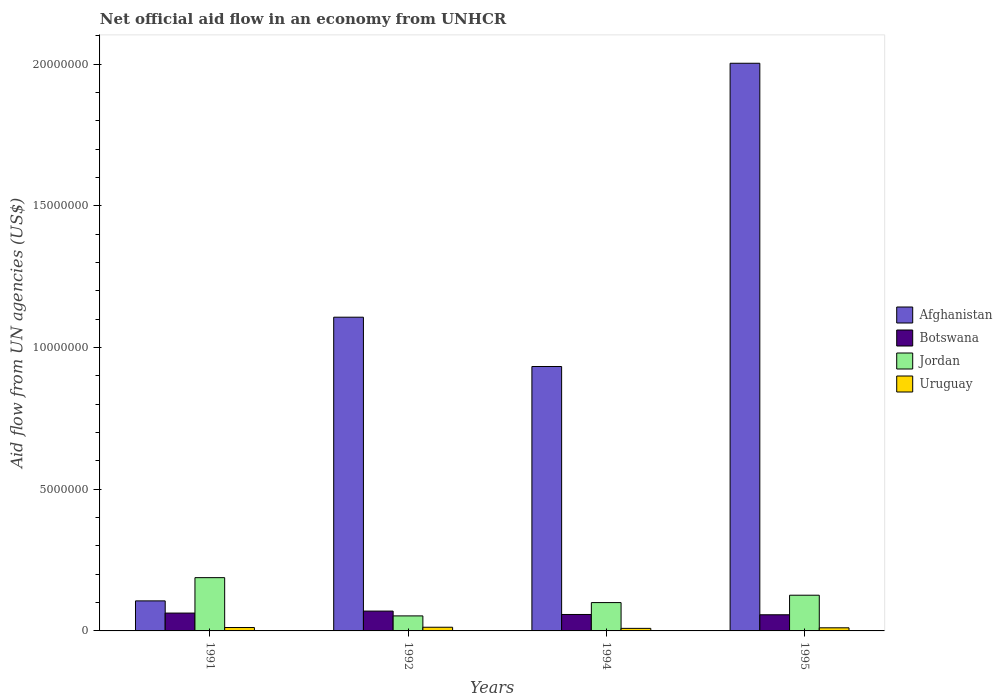How many different coloured bars are there?
Give a very brief answer. 4. Are the number of bars on each tick of the X-axis equal?
Ensure brevity in your answer.  Yes. How many bars are there on the 1st tick from the left?
Keep it short and to the point. 4. Across all years, what is the maximum net official aid flow in Afghanistan?
Make the answer very short. 2.00e+07. Across all years, what is the minimum net official aid flow in Jordan?
Provide a succinct answer. 5.30e+05. In which year was the net official aid flow in Jordan maximum?
Provide a succinct answer. 1991. In which year was the net official aid flow in Afghanistan minimum?
Keep it short and to the point. 1991. What is the total net official aid flow in Uruguay in the graph?
Your answer should be compact. 4.50e+05. What is the difference between the net official aid flow in Botswana in 1992 and that in 1994?
Make the answer very short. 1.20e+05. What is the difference between the net official aid flow in Afghanistan in 1994 and the net official aid flow in Uruguay in 1995?
Offer a terse response. 9.22e+06. What is the average net official aid flow in Uruguay per year?
Offer a terse response. 1.12e+05. In how many years, is the net official aid flow in Afghanistan greater than 4000000 US$?
Ensure brevity in your answer.  3. What is the ratio of the net official aid flow in Jordan in 1992 to that in 1995?
Your answer should be compact. 0.42. Is the net official aid flow in Botswana in 1992 less than that in 1994?
Give a very brief answer. No. What is the difference between the highest and the second highest net official aid flow in Jordan?
Your answer should be compact. 6.20e+05. What is the difference between the highest and the lowest net official aid flow in Afghanistan?
Offer a very short reply. 1.90e+07. In how many years, is the net official aid flow in Afghanistan greater than the average net official aid flow in Afghanistan taken over all years?
Your answer should be very brief. 2. Is the sum of the net official aid flow in Uruguay in 1991 and 1995 greater than the maximum net official aid flow in Jordan across all years?
Provide a short and direct response. No. What does the 1st bar from the left in 1991 represents?
Your answer should be compact. Afghanistan. What does the 2nd bar from the right in 1991 represents?
Provide a short and direct response. Jordan. Is it the case that in every year, the sum of the net official aid flow in Uruguay and net official aid flow in Afghanistan is greater than the net official aid flow in Jordan?
Offer a very short reply. No. Are all the bars in the graph horizontal?
Your answer should be very brief. No. How many years are there in the graph?
Give a very brief answer. 4. What is the difference between two consecutive major ticks on the Y-axis?
Keep it short and to the point. 5.00e+06. Are the values on the major ticks of Y-axis written in scientific E-notation?
Your response must be concise. No. Where does the legend appear in the graph?
Offer a terse response. Center right. How many legend labels are there?
Offer a very short reply. 4. How are the legend labels stacked?
Offer a terse response. Vertical. What is the title of the graph?
Offer a very short reply. Net official aid flow in an economy from UNHCR. What is the label or title of the X-axis?
Ensure brevity in your answer.  Years. What is the label or title of the Y-axis?
Give a very brief answer. Aid flow from UN agencies (US$). What is the Aid flow from UN agencies (US$) of Afghanistan in 1991?
Make the answer very short. 1.06e+06. What is the Aid flow from UN agencies (US$) of Botswana in 1991?
Provide a short and direct response. 6.30e+05. What is the Aid flow from UN agencies (US$) in Jordan in 1991?
Provide a short and direct response. 1.88e+06. What is the Aid flow from UN agencies (US$) in Afghanistan in 1992?
Provide a short and direct response. 1.11e+07. What is the Aid flow from UN agencies (US$) in Jordan in 1992?
Offer a terse response. 5.30e+05. What is the Aid flow from UN agencies (US$) of Afghanistan in 1994?
Your response must be concise. 9.33e+06. What is the Aid flow from UN agencies (US$) in Botswana in 1994?
Provide a succinct answer. 5.80e+05. What is the Aid flow from UN agencies (US$) in Jordan in 1994?
Keep it short and to the point. 1.00e+06. What is the Aid flow from UN agencies (US$) in Afghanistan in 1995?
Offer a very short reply. 2.00e+07. What is the Aid flow from UN agencies (US$) of Botswana in 1995?
Your response must be concise. 5.70e+05. What is the Aid flow from UN agencies (US$) in Jordan in 1995?
Offer a terse response. 1.26e+06. Across all years, what is the maximum Aid flow from UN agencies (US$) in Afghanistan?
Your response must be concise. 2.00e+07. Across all years, what is the maximum Aid flow from UN agencies (US$) of Jordan?
Keep it short and to the point. 1.88e+06. Across all years, what is the minimum Aid flow from UN agencies (US$) of Afghanistan?
Offer a terse response. 1.06e+06. Across all years, what is the minimum Aid flow from UN agencies (US$) of Botswana?
Your answer should be compact. 5.70e+05. Across all years, what is the minimum Aid flow from UN agencies (US$) in Jordan?
Give a very brief answer. 5.30e+05. What is the total Aid flow from UN agencies (US$) in Afghanistan in the graph?
Your answer should be compact. 4.15e+07. What is the total Aid flow from UN agencies (US$) of Botswana in the graph?
Keep it short and to the point. 2.48e+06. What is the total Aid flow from UN agencies (US$) in Jordan in the graph?
Provide a succinct answer. 4.67e+06. What is the difference between the Aid flow from UN agencies (US$) of Afghanistan in 1991 and that in 1992?
Your answer should be very brief. -1.00e+07. What is the difference between the Aid flow from UN agencies (US$) of Jordan in 1991 and that in 1992?
Your answer should be compact. 1.35e+06. What is the difference between the Aid flow from UN agencies (US$) of Afghanistan in 1991 and that in 1994?
Give a very brief answer. -8.27e+06. What is the difference between the Aid flow from UN agencies (US$) of Botswana in 1991 and that in 1994?
Your answer should be compact. 5.00e+04. What is the difference between the Aid flow from UN agencies (US$) of Jordan in 1991 and that in 1994?
Your answer should be compact. 8.80e+05. What is the difference between the Aid flow from UN agencies (US$) in Afghanistan in 1991 and that in 1995?
Your response must be concise. -1.90e+07. What is the difference between the Aid flow from UN agencies (US$) of Jordan in 1991 and that in 1995?
Your answer should be very brief. 6.20e+05. What is the difference between the Aid flow from UN agencies (US$) of Afghanistan in 1992 and that in 1994?
Your answer should be compact. 1.74e+06. What is the difference between the Aid flow from UN agencies (US$) of Jordan in 1992 and that in 1994?
Give a very brief answer. -4.70e+05. What is the difference between the Aid flow from UN agencies (US$) in Afghanistan in 1992 and that in 1995?
Offer a terse response. -8.96e+06. What is the difference between the Aid flow from UN agencies (US$) of Botswana in 1992 and that in 1995?
Keep it short and to the point. 1.30e+05. What is the difference between the Aid flow from UN agencies (US$) in Jordan in 1992 and that in 1995?
Your answer should be very brief. -7.30e+05. What is the difference between the Aid flow from UN agencies (US$) of Afghanistan in 1994 and that in 1995?
Provide a succinct answer. -1.07e+07. What is the difference between the Aid flow from UN agencies (US$) of Jordan in 1994 and that in 1995?
Offer a very short reply. -2.60e+05. What is the difference between the Aid flow from UN agencies (US$) in Uruguay in 1994 and that in 1995?
Keep it short and to the point. -2.00e+04. What is the difference between the Aid flow from UN agencies (US$) of Afghanistan in 1991 and the Aid flow from UN agencies (US$) of Jordan in 1992?
Keep it short and to the point. 5.30e+05. What is the difference between the Aid flow from UN agencies (US$) in Afghanistan in 1991 and the Aid flow from UN agencies (US$) in Uruguay in 1992?
Offer a very short reply. 9.30e+05. What is the difference between the Aid flow from UN agencies (US$) in Botswana in 1991 and the Aid flow from UN agencies (US$) in Jordan in 1992?
Keep it short and to the point. 1.00e+05. What is the difference between the Aid flow from UN agencies (US$) of Jordan in 1991 and the Aid flow from UN agencies (US$) of Uruguay in 1992?
Your response must be concise. 1.75e+06. What is the difference between the Aid flow from UN agencies (US$) of Afghanistan in 1991 and the Aid flow from UN agencies (US$) of Uruguay in 1994?
Your answer should be compact. 9.70e+05. What is the difference between the Aid flow from UN agencies (US$) of Botswana in 1991 and the Aid flow from UN agencies (US$) of Jordan in 1994?
Provide a short and direct response. -3.70e+05. What is the difference between the Aid flow from UN agencies (US$) of Botswana in 1991 and the Aid flow from UN agencies (US$) of Uruguay in 1994?
Make the answer very short. 5.40e+05. What is the difference between the Aid flow from UN agencies (US$) of Jordan in 1991 and the Aid flow from UN agencies (US$) of Uruguay in 1994?
Keep it short and to the point. 1.79e+06. What is the difference between the Aid flow from UN agencies (US$) of Afghanistan in 1991 and the Aid flow from UN agencies (US$) of Jordan in 1995?
Keep it short and to the point. -2.00e+05. What is the difference between the Aid flow from UN agencies (US$) of Afghanistan in 1991 and the Aid flow from UN agencies (US$) of Uruguay in 1995?
Make the answer very short. 9.50e+05. What is the difference between the Aid flow from UN agencies (US$) in Botswana in 1991 and the Aid flow from UN agencies (US$) in Jordan in 1995?
Keep it short and to the point. -6.30e+05. What is the difference between the Aid flow from UN agencies (US$) of Botswana in 1991 and the Aid flow from UN agencies (US$) of Uruguay in 1995?
Your response must be concise. 5.20e+05. What is the difference between the Aid flow from UN agencies (US$) in Jordan in 1991 and the Aid flow from UN agencies (US$) in Uruguay in 1995?
Your answer should be very brief. 1.77e+06. What is the difference between the Aid flow from UN agencies (US$) of Afghanistan in 1992 and the Aid flow from UN agencies (US$) of Botswana in 1994?
Offer a very short reply. 1.05e+07. What is the difference between the Aid flow from UN agencies (US$) in Afghanistan in 1992 and the Aid flow from UN agencies (US$) in Jordan in 1994?
Offer a very short reply. 1.01e+07. What is the difference between the Aid flow from UN agencies (US$) in Afghanistan in 1992 and the Aid flow from UN agencies (US$) in Uruguay in 1994?
Provide a succinct answer. 1.10e+07. What is the difference between the Aid flow from UN agencies (US$) of Jordan in 1992 and the Aid flow from UN agencies (US$) of Uruguay in 1994?
Offer a very short reply. 4.40e+05. What is the difference between the Aid flow from UN agencies (US$) in Afghanistan in 1992 and the Aid flow from UN agencies (US$) in Botswana in 1995?
Your answer should be very brief. 1.05e+07. What is the difference between the Aid flow from UN agencies (US$) of Afghanistan in 1992 and the Aid flow from UN agencies (US$) of Jordan in 1995?
Offer a very short reply. 9.81e+06. What is the difference between the Aid flow from UN agencies (US$) in Afghanistan in 1992 and the Aid flow from UN agencies (US$) in Uruguay in 1995?
Ensure brevity in your answer.  1.10e+07. What is the difference between the Aid flow from UN agencies (US$) in Botswana in 1992 and the Aid flow from UN agencies (US$) in Jordan in 1995?
Make the answer very short. -5.60e+05. What is the difference between the Aid flow from UN agencies (US$) of Botswana in 1992 and the Aid flow from UN agencies (US$) of Uruguay in 1995?
Offer a terse response. 5.90e+05. What is the difference between the Aid flow from UN agencies (US$) in Afghanistan in 1994 and the Aid flow from UN agencies (US$) in Botswana in 1995?
Provide a succinct answer. 8.76e+06. What is the difference between the Aid flow from UN agencies (US$) in Afghanistan in 1994 and the Aid flow from UN agencies (US$) in Jordan in 1995?
Give a very brief answer. 8.07e+06. What is the difference between the Aid flow from UN agencies (US$) in Afghanistan in 1994 and the Aid flow from UN agencies (US$) in Uruguay in 1995?
Provide a short and direct response. 9.22e+06. What is the difference between the Aid flow from UN agencies (US$) in Botswana in 1994 and the Aid flow from UN agencies (US$) in Jordan in 1995?
Your response must be concise. -6.80e+05. What is the difference between the Aid flow from UN agencies (US$) in Botswana in 1994 and the Aid flow from UN agencies (US$) in Uruguay in 1995?
Offer a very short reply. 4.70e+05. What is the difference between the Aid flow from UN agencies (US$) of Jordan in 1994 and the Aid flow from UN agencies (US$) of Uruguay in 1995?
Make the answer very short. 8.90e+05. What is the average Aid flow from UN agencies (US$) of Afghanistan per year?
Provide a short and direct response. 1.04e+07. What is the average Aid flow from UN agencies (US$) in Botswana per year?
Your answer should be very brief. 6.20e+05. What is the average Aid flow from UN agencies (US$) in Jordan per year?
Ensure brevity in your answer.  1.17e+06. What is the average Aid flow from UN agencies (US$) of Uruguay per year?
Your response must be concise. 1.12e+05. In the year 1991, what is the difference between the Aid flow from UN agencies (US$) in Afghanistan and Aid flow from UN agencies (US$) in Jordan?
Provide a succinct answer. -8.20e+05. In the year 1991, what is the difference between the Aid flow from UN agencies (US$) in Afghanistan and Aid flow from UN agencies (US$) in Uruguay?
Keep it short and to the point. 9.40e+05. In the year 1991, what is the difference between the Aid flow from UN agencies (US$) of Botswana and Aid flow from UN agencies (US$) of Jordan?
Give a very brief answer. -1.25e+06. In the year 1991, what is the difference between the Aid flow from UN agencies (US$) of Botswana and Aid flow from UN agencies (US$) of Uruguay?
Give a very brief answer. 5.10e+05. In the year 1991, what is the difference between the Aid flow from UN agencies (US$) in Jordan and Aid flow from UN agencies (US$) in Uruguay?
Ensure brevity in your answer.  1.76e+06. In the year 1992, what is the difference between the Aid flow from UN agencies (US$) of Afghanistan and Aid flow from UN agencies (US$) of Botswana?
Offer a terse response. 1.04e+07. In the year 1992, what is the difference between the Aid flow from UN agencies (US$) of Afghanistan and Aid flow from UN agencies (US$) of Jordan?
Give a very brief answer. 1.05e+07. In the year 1992, what is the difference between the Aid flow from UN agencies (US$) of Afghanistan and Aid flow from UN agencies (US$) of Uruguay?
Make the answer very short. 1.09e+07. In the year 1992, what is the difference between the Aid flow from UN agencies (US$) of Botswana and Aid flow from UN agencies (US$) of Uruguay?
Offer a very short reply. 5.70e+05. In the year 1994, what is the difference between the Aid flow from UN agencies (US$) of Afghanistan and Aid flow from UN agencies (US$) of Botswana?
Give a very brief answer. 8.75e+06. In the year 1994, what is the difference between the Aid flow from UN agencies (US$) in Afghanistan and Aid flow from UN agencies (US$) in Jordan?
Your answer should be very brief. 8.33e+06. In the year 1994, what is the difference between the Aid flow from UN agencies (US$) in Afghanistan and Aid flow from UN agencies (US$) in Uruguay?
Offer a very short reply. 9.24e+06. In the year 1994, what is the difference between the Aid flow from UN agencies (US$) in Botswana and Aid flow from UN agencies (US$) in Jordan?
Keep it short and to the point. -4.20e+05. In the year 1994, what is the difference between the Aid flow from UN agencies (US$) in Botswana and Aid flow from UN agencies (US$) in Uruguay?
Your answer should be very brief. 4.90e+05. In the year 1994, what is the difference between the Aid flow from UN agencies (US$) of Jordan and Aid flow from UN agencies (US$) of Uruguay?
Your answer should be very brief. 9.10e+05. In the year 1995, what is the difference between the Aid flow from UN agencies (US$) in Afghanistan and Aid flow from UN agencies (US$) in Botswana?
Provide a succinct answer. 1.95e+07. In the year 1995, what is the difference between the Aid flow from UN agencies (US$) in Afghanistan and Aid flow from UN agencies (US$) in Jordan?
Give a very brief answer. 1.88e+07. In the year 1995, what is the difference between the Aid flow from UN agencies (US$) of Afghanistan and Aid flow from UN agencies (US$) of Uruguay?
Provide a short and direct response. 1.99e+07. In the year 1995, what is the difference between the Aid flow from UN agencies (US$) in Botswana and Aid flow from UN agencies (US$) in Jordan?
Your response must be concise. -6.90e+05. In the year 1995, what is the difference between the Aid flow from UN agencies (US$) of Jordan and Aid flow from UN agencies (US$) of Uruguay?
Offer a very short reply. 1.15e+06. What is the ratio of the Aid flow from UN agencies (US$) in Afghanistan in 1991 to that in 1992?
Your response must be concise. 0.1. What is the ratio of the Aid flow from UN agencies (US$) of Botswana in 1991 to that in 1992?
Keep it short and to the point. 0.9. What is the ratio of the Aid flow from UN agencies (US$) in Jordan in 1991 to that in 1992?
Provide a succinct answer. 3.55. What is the ratio of the Aid flow from UN agencies (US$) in Uruguay in 1991 to that in 1992?
Provide a succinct answer. 0.92. What is the ratio of the Aid flow from UN agencies (US$) of Afghanistan in 1991 to that in 1994?
Offer a very short reply. 0.11. What is the ratio of the Aid flow from UN agencies (US$) in Botswana in 1991 to that in 1994?
Make the answer very short. 1.09. What is the ratio of the Aid flow from UN agencies (US$) of Jordan in 1991 to that in 1994?
Offer a very short reply. 1.88. What is the ratio of the Aid flow from UN agencies (US$) in Uruguay in 1991 to that in 1994?
Offer a terse response. 1.33. What is the ratio of the Aid flow from UN agencies (US$) of Afghanistan in 1991 to that in 1995?
Your response must be concise. 0.05. What is the ratio of the Aid flow from UN agencies (US$) in Botswana in 1991 to that in 1995?
Give a very brief answer. 1.11. What is the ratio of the Aid flow from UN agencies (US$) of Jordan in 1991 to that in 1995?
Provide a short and direct response. 1.49. What is the ratio of the Aid flow from UN agencies (US$) of Afghanistan in 1992 to that in 1994?
Offer a very short reply. 1.19. What is the ratio of the Aid flow from UN agencies (US$) in Botswana in 1992 to that in 1994?
Keep it short and to the point. 1.21. What is the ratio of the Aid flow from UN agencies (US$) of Jordan in 1992 to that in 1994?
Make the answer very short. 0.53. What is the ratio of the Aid flow from UN agencies (US$) in Uruguay in 1992 to that in 1994?
Your answer should be compact. 1.44. What is the ratio of the Aid flow from UN agencies (US$) of Afghanistan in 1992 to that in 1995?
Your answer should be very brief. 0.55. What is the ratio of the Aid flow from UN agencies (US$) of Botswana in 1992 to that in 1995?
Your response must be concise. 1.23. What is the ratio of the Aid flow from UN agencies (US$) of Jordan in 1992 to that in 1995?
Ensure brevity in your answer.  0.42. What is the ratio of the Aid flow from UN agencies (US$) in Uruguay in 1992 to that in 1995?
Your answer should be compact. 1.18. What is the ratio of the Aid flow from UN agencies (US$) of Afghanistan in 1994 to that in 1995?
Your response must be concise. 0.47. What is the ratio of the Aid flow from UN agencies (US$) of Botswana in 1994 to that in 1995?
Give a very brief answer. 1.02. What is the ratio of the Aid flow from UN agencies (US$) in Jordan in 1994 to that in 1995?
Give a very brief answer. 0.79. What is the ratio of the Aid flow from UN agencies (US$) of Uruguay in 1994 to that in 1995?
Ensure brevity in your answer.  0.82. What is the difference between the highest and the second highest Aid flow from UN agencies (US$) of Afghanistan?
Make the answer very short. 8.96e+06. What is the difference between the highest and the second highest Aid flow from UN agencies (US$) in Botswana?
Give a very brief answer. 7.00e+04. What is the difference between the highest and the second highest Aid flow from UN agencies (US$) of Jordan?
Keep it short and to the point. 6.20e+05. What is the difference between the highest and the second highest Aid flow from UN agencies (US$) of Uruguay?
Offer a terse response. 10000. What is the difference between the highest and the lowest Aid flow from UN agencies (US$) in Afghanistan?
Your answer should be compact. 1.90e+07. What is the difference between the highest and the lowest Aid flow from UN agencies (US$) in Botswana?
Make the answer very short. 1.30e+05. What is the difference between the highest and the lowest Aid flow from UN agencies (US$) of Jordan?
Provide a succinct answer. 1.35e+06. 